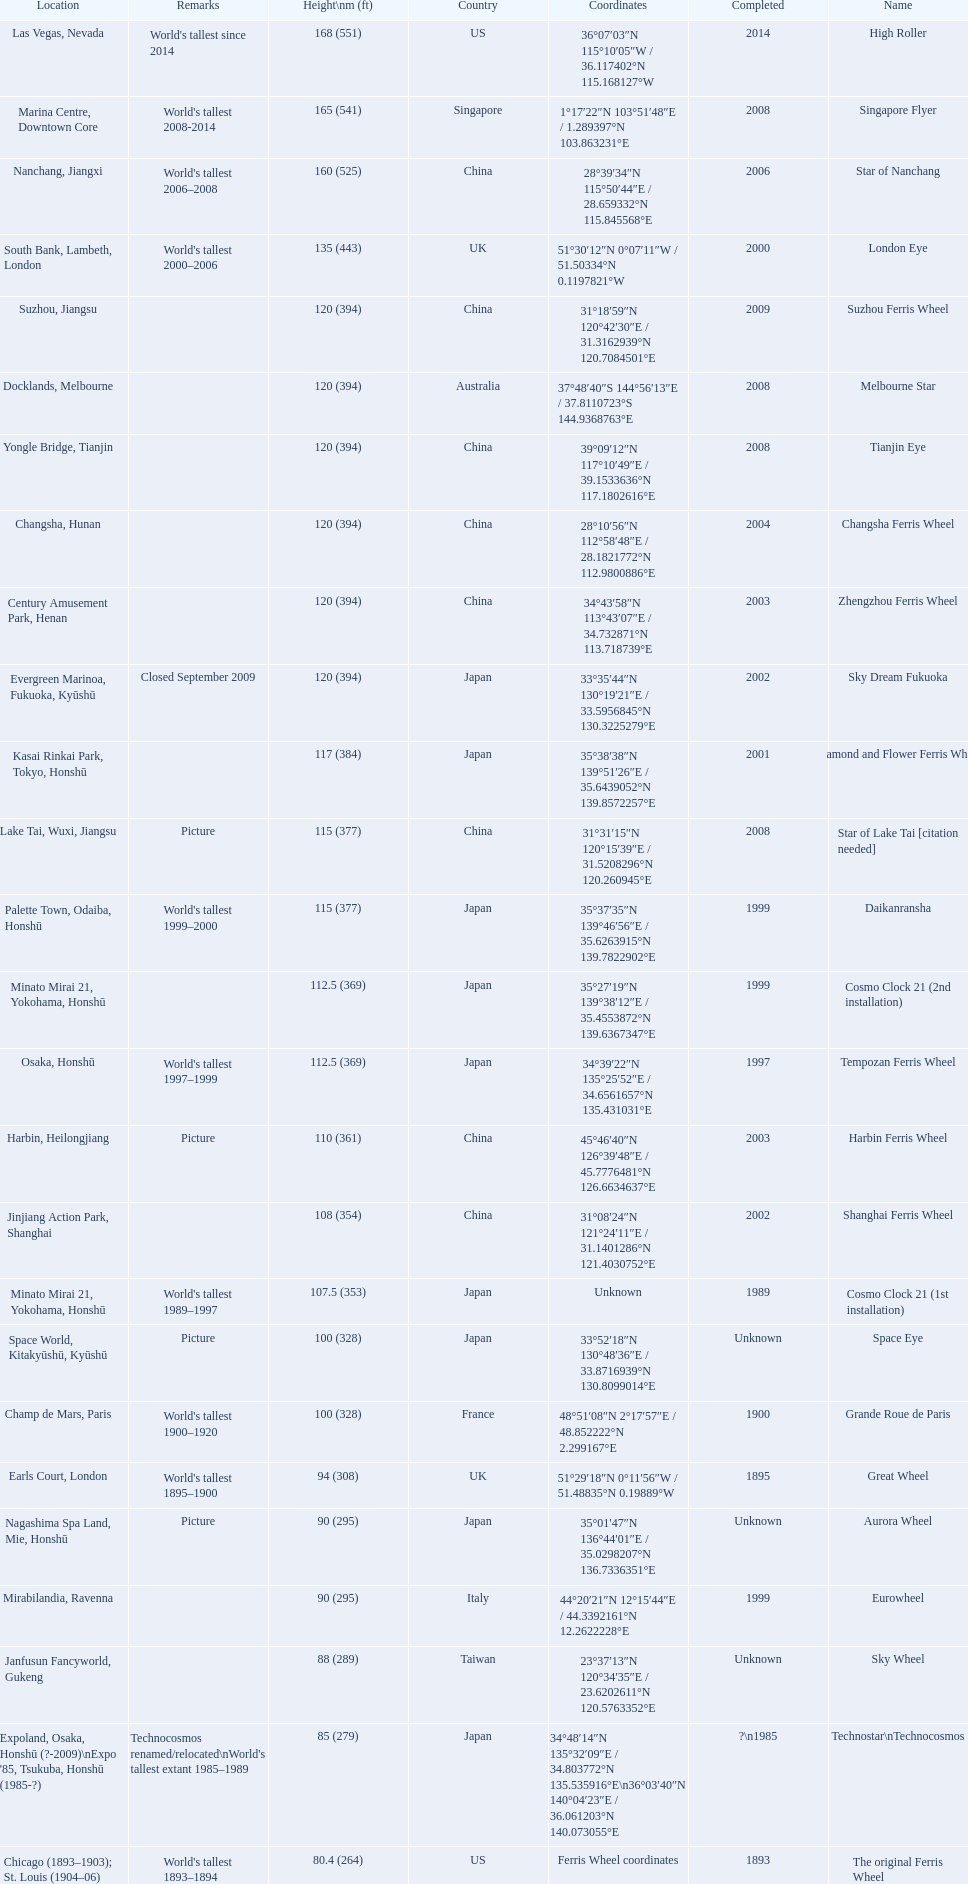What are all of the ferris wheel names? High Roller, Singapore Flyer, Star of Nanchang, London Eye, Suzhou Ferris Wheel, Melbourne Star, Tianjin Eye, Changsha Ferris Wheel, Zhengzhou Ferris Wheel, Sky Dream Fukuoka, Diamond and Flower Ferris Wheel, Star of Lake Tai [citation needed], Daikanransha, Cosmo Clock 21 (2nd installation), Tempozan Ferris Wheel, Harbin Ferris Wheel, Shanghai Ferris Wheel, Cosmo Clock 21 (1st installation), Space Eye, Grande Roue de Paris, Great Wheel, Aurora Wheel, Eurowheel, Sky Wheel, Technostar\nTechnocosmos, The original Ferris Wheel. What was the height of each one? 168 (551), 165 (541), 160 (525), 135 (443), 120 (394), 120 (394), 120 (394), 120 (394), 120 (394), 120 (394), 117 (384), 115 (377), 115 (377), 112.5 (369), 112.5 (369), 110 (361), 108 (354), 107.5 (353), 100 (328), 100 (328), 94 (308), 90 (295), 90 (295), 88 (289), 85 (279), 80.4 (264). And when were they completed? 2014, 2008, 2006, 2000, 2009, 2008, 2008, 2004, 2003, 2002, 2001, 2008, 1999, 1999, 1997, 2003, 2002, 1989, Unknown, 1900, 1895, Unknown, 1999, Unknown, ?\n1985, 1893. Which were completed in 2008? Singapore Flyer, Melbourne Star, Tianjin Eye, Star of Lake Tai [citation needed]. And of those ferris wheels, which had a height of 165 meters? Singapore Flyer. 